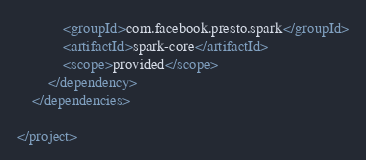<code> <loc_0><loc_0><loc_500><loc_500><_XML_>            <groupId>com.facebook.presto.spark</groupId>
            <artifactId>spark-core</artifactId>
            <scope>provided</scope>
        </dependency>
    </dependencies>

</project>
</code> 